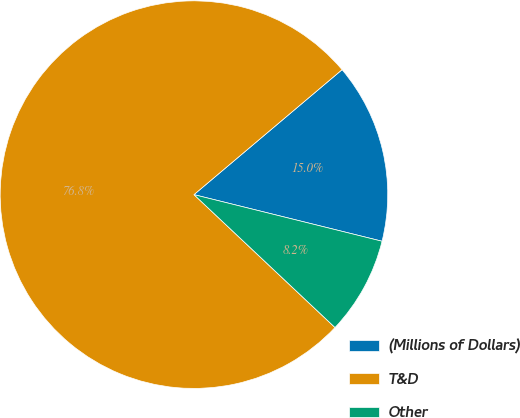Convert chart. <chart><loc_0><loc_0><loc_500><loc_500><pie_chart><fcel>(Millions of Dollars)<fcel>T&D<fcel>Other<nl><fcel>15.02%<fcel>76.82%<fcel>8.16%<nl></chart> 